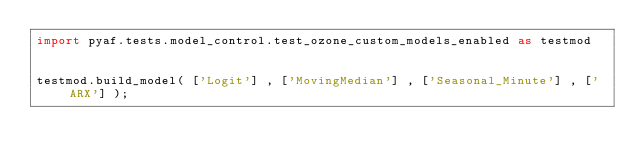Convert code to text. <code><loc_0><loc_0><loc_500><loc_500><_Python_>import pyaf.tests.model_control.test_ozone_custom_models_enabled as testmod


testmod.build_model( ['Logit'] , ['MovingMedian'] , ['Seasonal_Minute'] , ['ARX'] );</code> 